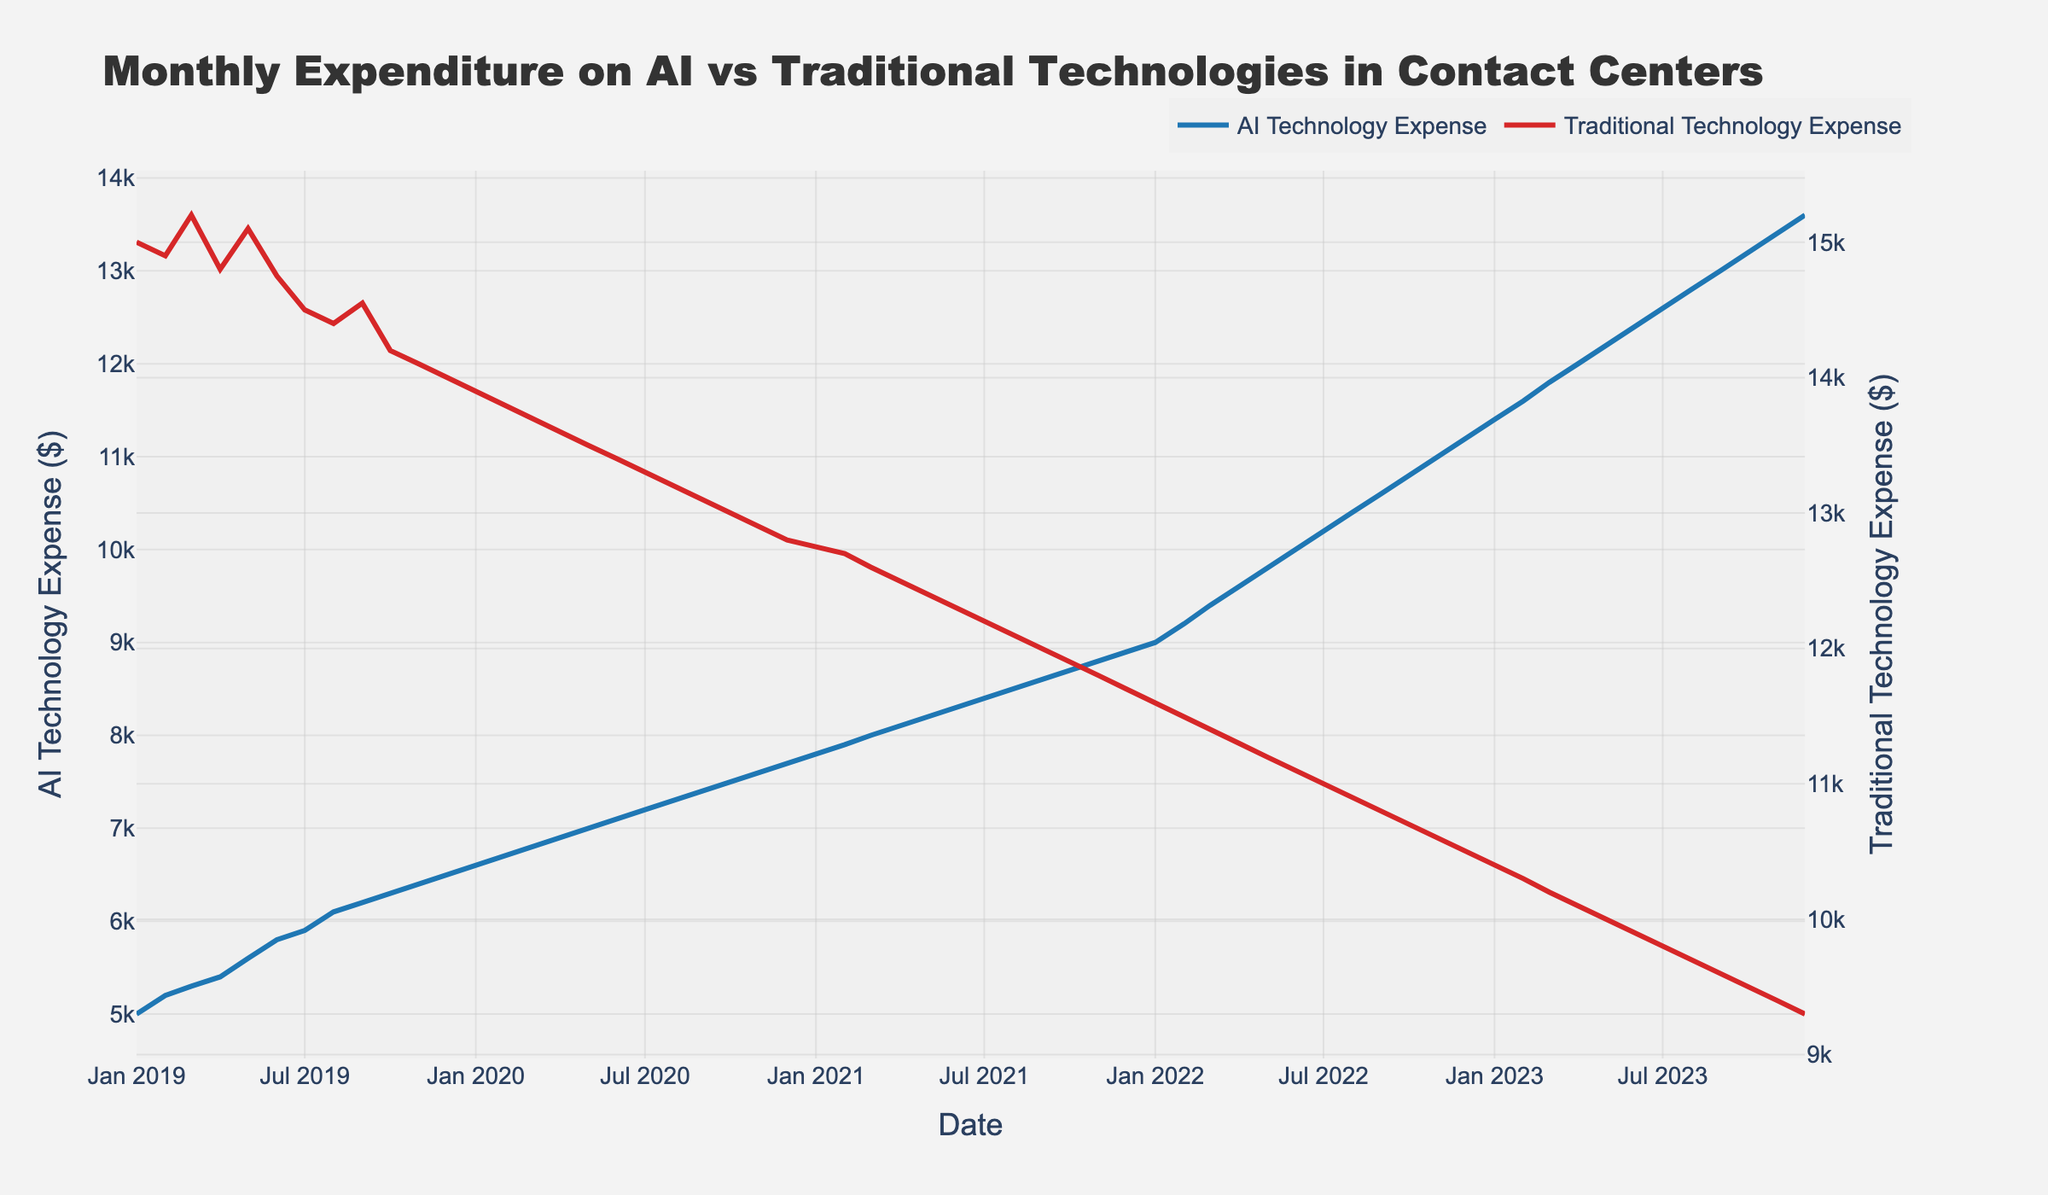What is the title of the plot? The title is usually positioned at the top center of the plot and provides a brief overview of what the plot represents.
Answer: Monthly Expenditure on AI vs Traditional Technologies in Contact Centers What are the y-axis labels for the two technologies? The y-axis labels are meant to indicate what each axis represents. This plot has two y-axes, one for each technology expenditure.
Answer: AI Technology Expense ($) and Traditional Technology Expense ($) According to the plot, what is the AI technology expense for August 2021? Identify the data point for August 2021 by locating it on the x-axis and then reading the corresponding value on the y-axis for the AI Technology expense.
Answer: $8,500 How does the spending on traditional technology in December 2022 compare to December 2021? Locate the data points for December 2021 and December 2022 on the traditional technology (right y-axis) line, then compare the values.
Answer: December 2022 ($10,500) is lower than December 2021 ($11,700) What trend can be observed for AI technology expenses over the 4 years? Observe the overall pattern in the AI technology expense line from 2019 to 2023.
Answer: Generally increasing What is the difference between AI technology and traditional technology expenses in January 2023? Find the values for both expenses in January 2023 and subtract the traditional technology expense from the AI technology expense.
Answer: $1,400 ($11,400 - $10,000) In which month and year did the traditional technology expenditure first drop below $12,000? Track the downward trend on the traditional technology expenditure line and identify the first data point where the value drops below $12,000.
Answer: September 2021 What is the total expenditure on AI technology for the entire year of 2020? Sum all the monthly AI technology expenses for the year 2020.
(6600 + 6700 + 6800 + 6900 + 7000 + 7100 + 7200 + 7300 + 7400 + 7500 + 7600 + 7700)
Answer: $85,200 Which months show a consistent increase in AI technology expenditure without any decrease? Examine the AI technology expenditure line for consecutive data points without any decline in value.
Answer: Throughout entire period shown in figure Do AI technology and traditional technology expenses ever cross each other on the plot? Check for any point on the plot where the lines for both expenses intersect.
Answer: No 